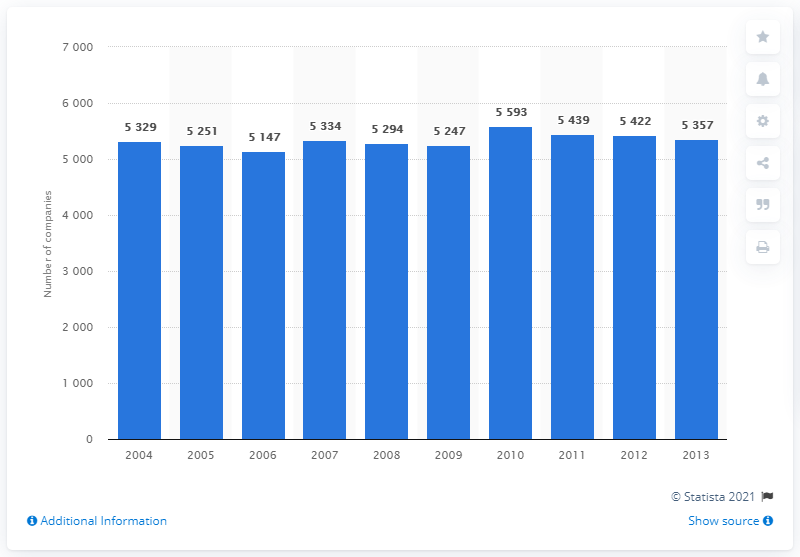How many companies were active in the insurance sector by the end of 2013? By the end of 2013, there were 5,357 companies actively operating in the insurance sector. 